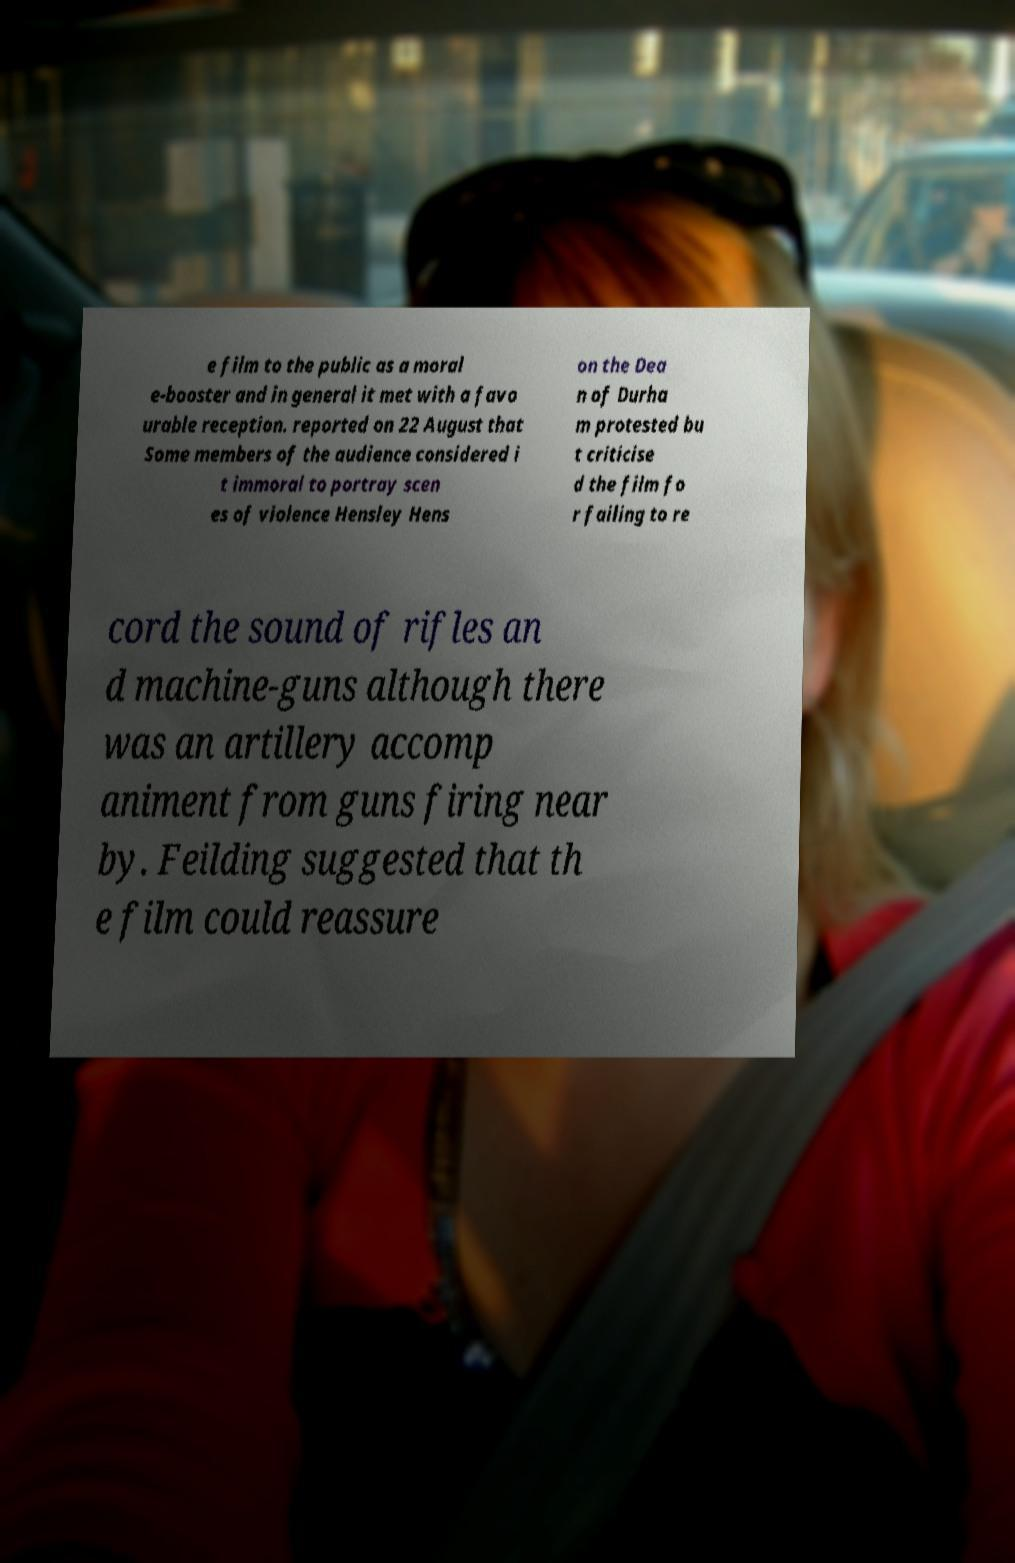There's text embedded in this image that I need extracted. Can you transcribe it verbatim? e film to the public as a moral e-booster and in general it met with a favo urable reception. reported on 22 August that Some members of the audience considered i t immoral to portray scen es of violence Hensley Hens on the Dea n of Durha m protested bu t criticise d the film fo r failing to re cord the sound of rifles an d machine-guns although there was an artillery accomp animent from guns firing near by. Feilding suggested that th e film could reassure 